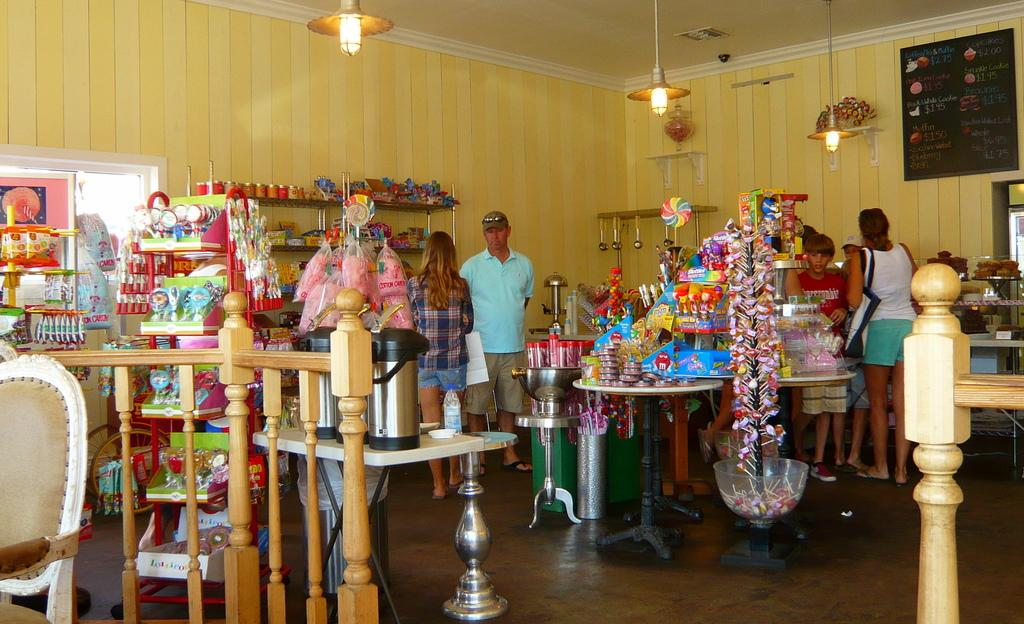What can be seen in the image involving people? There are people standing in the image. What type of establishment is present in the image? There is a shop in the image. What specific items can be found in the shop? The shop contains lollipops, candies, and other bakery items. What type of plant is being sold in the shop? There is no plant being sold in the shop; it contains lollipops, candies, and other bakery items. Can you see a dog inside the shop? There is no dog present in the image. 